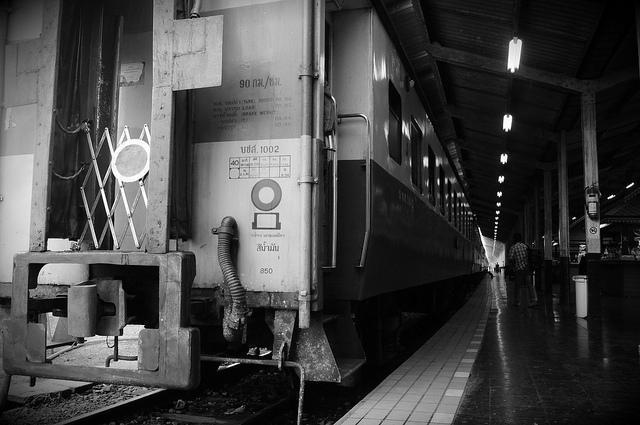How many horns does the truck have on each side?
Give a very brief answer. 0. 